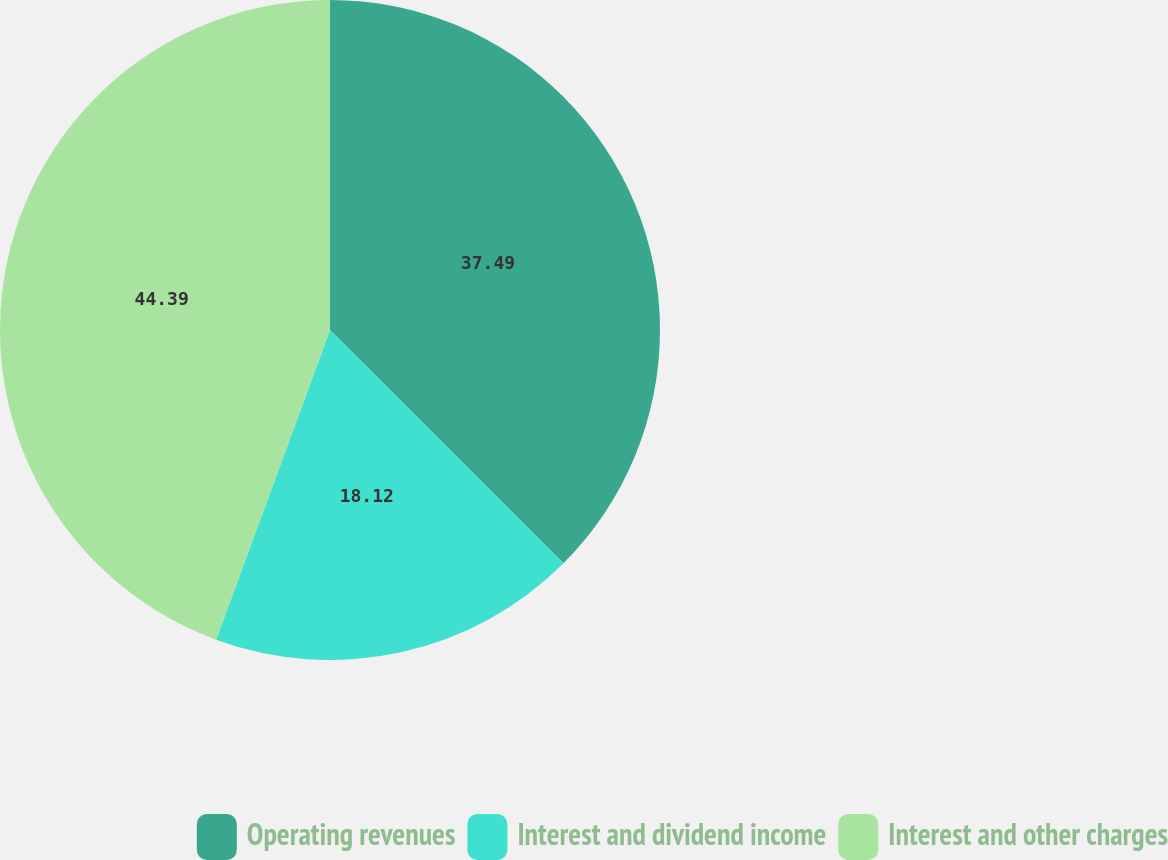Convert chart. <chart><loc_0><loc_0><loc_500><loc_500><pie_chart><fcel>Operating revenues<fcel>Interest and dividend income<fcel>Interest and other charges<nl><fcel>37.49%<fcel>18.12%<fcel>44.39%<nl></chart> 